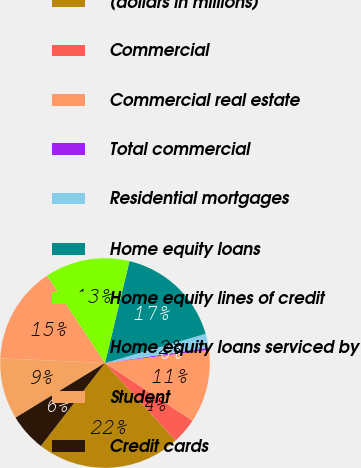Convert chart. <chart><loc_0><loc_0><loc_500><loc_500><pie_chart><fcel>(dollars in millions)<fcel>Commercial<fcel>Commercial real estate<fcel>Total commercial<fcel>Residential mortgages<fcel>Home equity loans<fcel>Home equity lines of credit<fcel>Home equity loans serviced by<fcel>Student<fcel>Credit cards<nl><fcel>22.22%<fcel>3.98%<fcel>11.28%<fcel>0.33%<fcel>2.16%<fcel>16.75%<fcel>13.1%<fcel>14.93%<fcel>9.45%<fcel>5.8%<nl></chart> 